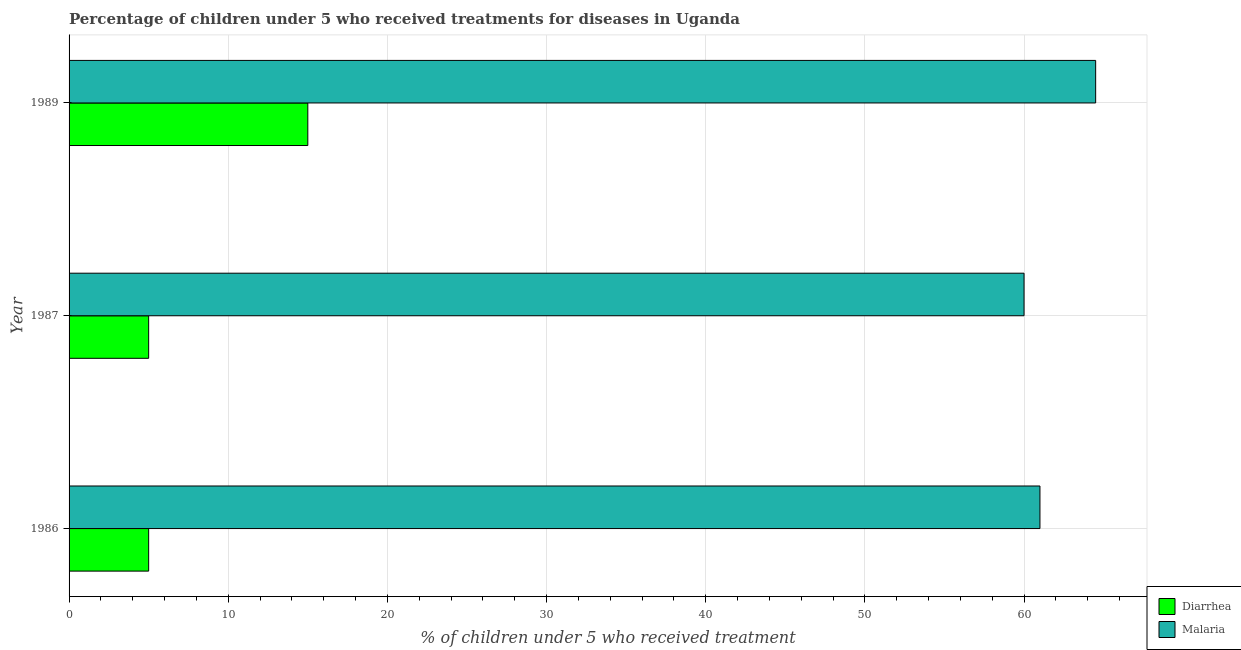How many different coloured bars are there?
Provide a succinct answer. 2. Are the number of bars per tick equal to the number of legend labels?
Keep it short and to the point. Yes. In how many cases, is the number of bars for a given year not equal to the number of legend labels?
Keep it short and to the point. 0. What is the percentage of children who received treatment for malaria in 1989?
Provide a short and direct response. 64.5. Across all years, what is the maximum percentage of children who received treatment for diarrhoea?
Keep it short and to the point. 15. In which year was the percentage of children who received treatment for malaria minimum?
Your answer should be very brief. 1987. What is the total percentage of children who received treatment for malaria in the graph?
Give a very brief answer. 185.5. What is the difference between the percentage of children who received treatment for diarrhoea in 1986 and that in 1989?
Provide a succinct answer. -10. What is the difference between the percentage of children who received treatment for diarrhoea in 1987 and the percentage of children who received treatment for malaria in 1986?
Provide a short and direct response. -56. What is the average percentage of children who received treatment for malaria per year?
Provide a succinct answer. 61.83. In the year 1986, what is the difference between the percentage of children who received treatment for malaria and percentage of children who received treatment for diarrhoea?
Your answer should be compact. 56. In how many years, is the percentage of children who received treatment for diarrhoea greater than 60 %?
Offer a terse response. 0. What is the ratio of the percentage of children who received treatment for diarrhoea in 1987 to that in 1989?
Give a very brief answer. 0.33. Is the percentage of children who received treatment for malaria in 1987 less than that in 1989?
Provide a succinct answer. Yes. What is the difference between the highest and the second highest percentage of children who received treatment for diarrhoea?
Give a very brief answer. 10. What is the difference between the highest and the lowest percentage of children who received treatment for malaria?
Give a very brief answer. 4.5. Is the sum of the percentage of children who received treatment for diarrhoea in 1987 and 1989 greater than the maximum percentage of children who received treatment for malaria across all years?
Make the answer very short. No. What does the 2nd bar from the top in 1986 represents?
Offer a terse response. Diarrhea. What does the 2nd bar from the bottom in 1986 represents?
Your response must be concise. Malaria. How many bars are there?
Your response must be concise. 6. Are all the bars in the graph horizontal?
Make the answer very short. Yes. Does the graph contain grids?
Make the answer very short. Yes. Where does the legend appear in the graph?
Ensure brevity in your answer.  Bottom right. How many legend labels are there?
Offer a very short reply. 2. What is the title of the graph?
Your answer should be compact. Percentage of children under 5 who received treatments for diseases in Uganda. Does "Female labor force" appear as one of the legend labels in the graph?
Your response must be concise. No. What is the label or title of the X-axis?
Offer a very short reply. % of children under 5 who received treatment. What is the % of children under 5 who received treatment in Malaria in 1986?
Provide a succinct answer. 61. What is the % of children under 5 who received treatment in Malaria in 1987?
Offer a terse response. 60. What is the % of children under 5 who received treatment of Diarrhea in 1989?
Your response must be concise. 15. What is the % of children under 5 who received treatment of Malaria in 1989?
Ensure brevity in your answer.  64.5. Across all years, what is the maximum % of children under 5 who received treatment in Diarrhea?
Your response must be concise. 15. Across all years, what is the maximum % of children under 5 who received treatment in Malaria?
Give a very brief answer. 64.5. Across all years, what is the minimum % of children under 5 who received treatment in Malaria?
Make the answer very short. 60. What is the total % of children under 5 who received treatment of Diarrhea in the graph?
Your response must be concise. 25. What is the total % of children under 5 who received treatment of Malaria in the graph?
Provide a succinct answer. 185.5. What is the difference between the % of children under 5 who received treatment in Diarrhea in 1986 and that in 1989?
Your answer should be compact. -10. What is the difference between the % of children under 5 who received treatment in Diarrhea in 1987 and that in 1989?
Give a very brief answer. -10. What is the difference between the % of children under 5 who received treatment of Diarrhea in 1986 and the % of children under 5 who received treatment of Malaria in 1987?
Give a very brief answer. -55. What is the difference between the % of children under 5 who received treatment of Diarrhea in 1986 and the % of children under 5 who received treatment of Malaria in 1989?
Provide a succinct answer. -59.5. What is the difference between the % of children under 5 who received treatment in Diarrhea in 1987 and the % of children under 5 who received treatment in Malaria in 1989?
Ensure brevity in your answer.  -59.5. What is the average % of children under 5 who received treatment in Diarrhea per year?
Your answer should be very brief. 8.33. What is the average % of children under 5 who received treatment in Malaria per year?
Your answer should be compact. 61.83. In the year 1986, what is the difference between the % of children under 5 who received treatment in Diarrhea and % of children under 5 who received treatment in Malaria?
Give a very brief answer. -56. In the year 1987, what is the difference between the % of children under 5 who received treatment in Diarrhea and % of children under 5 who received treatment in Malaria?
Your response must be concise. -55. In the year 1989, what is the difference between the % of children under 5 who received treatment of Diarrhea and % of children under 5 who received treatment of Malaria?
Make the answer very short. -49.5. What is the ratio of the % of children under 5 who received treatment in Diarrhea in 1986 to that in 1987?
Your answer should be very brief. 1. What is the ratio of the % of children under 5 who received treatment in Malaria in 1986 to that in 1987?
Ensure brevity in your answer.  1.02. What is the ratio of the % of children under 5 who received treatment in Malaria in 1986 to that in 1989?
Offer a very short reply. 0.95. What is the ratio of the % of children under 5 who received treatment of Malaria in 1987 to that in 1989?
Offer a terse response. 0.93. What is the difference between the highest and the second highest % of children under 5 who received treatment in Diarrhea?
Offer a very short reply. 10. What is the difference between the highest and the lowest % of children under 5 who received treatment in Diarrhea?
Provide a succinct answer. 10. 